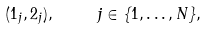<formula> <loc_0><loc_0><loc_500><loc_500>( 1 _ { j } , 2 _ { j } ) , \ \quad j \in \{ 1 , \dots , N \} ,</formula> 